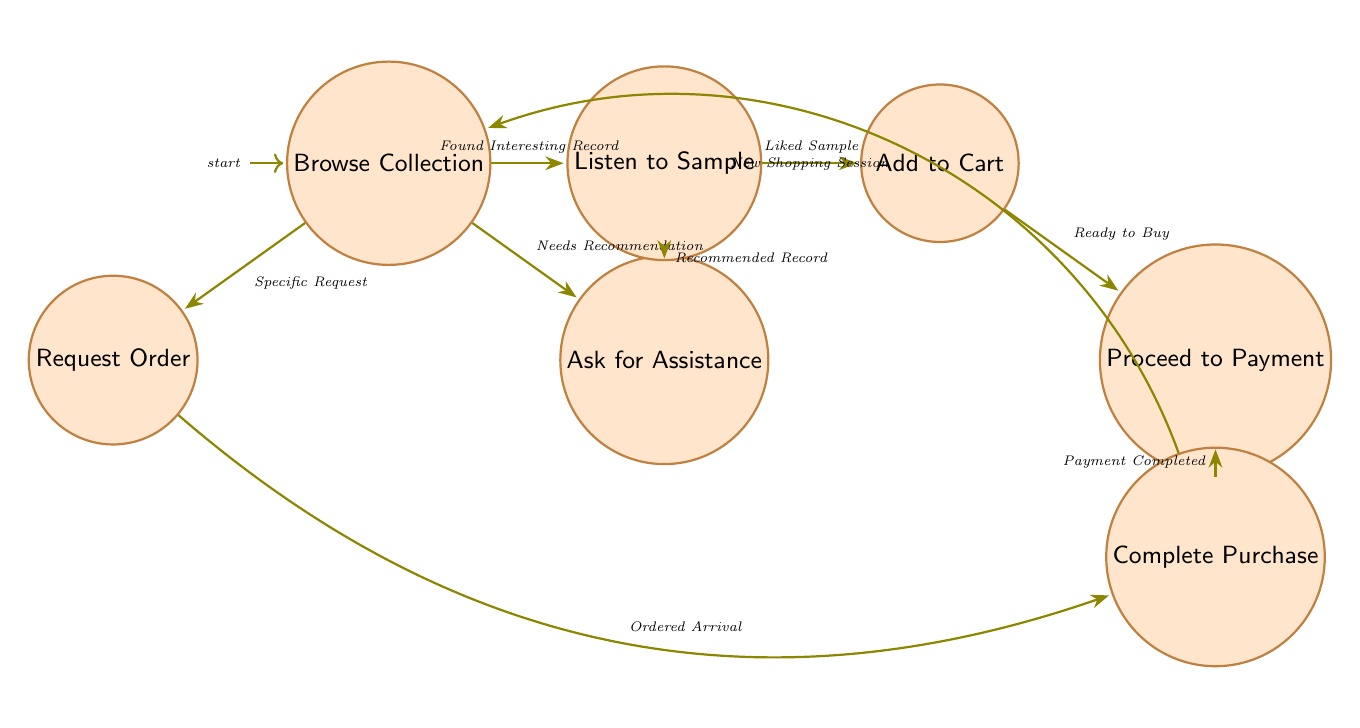What are the states in the diagram? The states in the diagram represent various steps a customer might take during their purchase journey in the vinyl record shop. The specific states are: Browse Collection, Ask for Assistance, Listen to Sample, Add to Cart, Proceed to Payment, Complete Purchase, and Request Order.
Answer: Browse Collection, Ask for Assistance, Listen to Sample, Add to Cart, Proceed to Payment, Complete Purchase, Request Order How many transitions are depicted in the diagram? The diagram shows the paths that customers can take from one state to another, referred to as transitions. There are a total of 9 transitions, as outlined in the transition section of the data.
Answer: 9 What triggers the transition from "Browse Collection" to "Listen to Sample"? The transition from "Browse Collection" to "Listen to Sample" occurs when a customer finds an interesting record they want to explore further. This specific trigger is labelled as "Found Interesting Record."
Answer: Found Interesting Record What is the final state a customer reaches after "Complete Purchase" if they start a new shopping session? After "Complete Purchase," if the customer wants to start a new shopping session, they transition back to "Browse Collection." This return is specifically triggered by "New Shopping Session."
Answer: Browse Collection What is the relationship between "Request Order" and "Complete Purchase"? The relationship between "Request Order" and "Complete Purchase" shows that after requesting an order for a record not currently in stock, the customer can complete their purchase when the ordered item arrives. This is triggered by "Ordered Arrival."
Answer: Ordered Arrival How many initial states are there in the diagram? The diagram begins with one initial state, which is "Browse Collection." This is the starting point for the customer’s journey in the finite state machine.
Answer: 1 Which state does a customer enter after listening to a sample they liked? After a customer listens to a sample and enjoys it, they will proceed to add that record to their shopping cart. This is indicated by the trigger "Liked Sample."
Answer: Add to Cart What initiates the "Ask for Assistance" state from "Browse Collection"? The customer transitions to the "Ask for Assistance" state from "Browse Collection" when they perceive a need for recommendations. This is recognized as the trigger "Needs Recommendation."
Answer: Needs Recommendation 